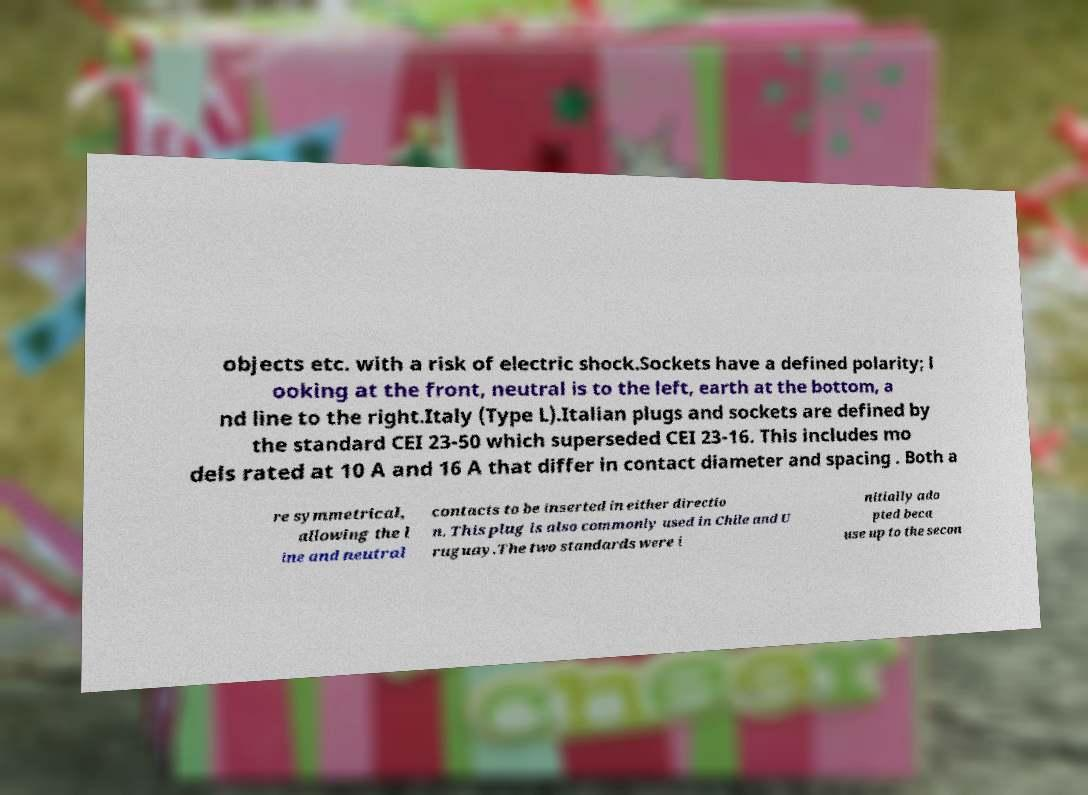I need the written content from this picture converted into text. Can you do that? objects etc. with a risk of electric shock.Sockets have a defined polarity; l ooking at the front, neutral is to the left, earth at the bottom, a nd line to the right.Italy (Type L).Italian plugs and sockets are defined by the standard CEI 23-50 which superseded CEI 23-16. This includes mo dels rated at 10 A and 16 A that differ in contact diameter and spacing . Both a re symmetrical, allowing the l ine and neutral contacts to be inserted in either directio n. This plug is also commonly used in Chile and U ruguay.The two standards were i nitially ado pted beca use up to the secon 